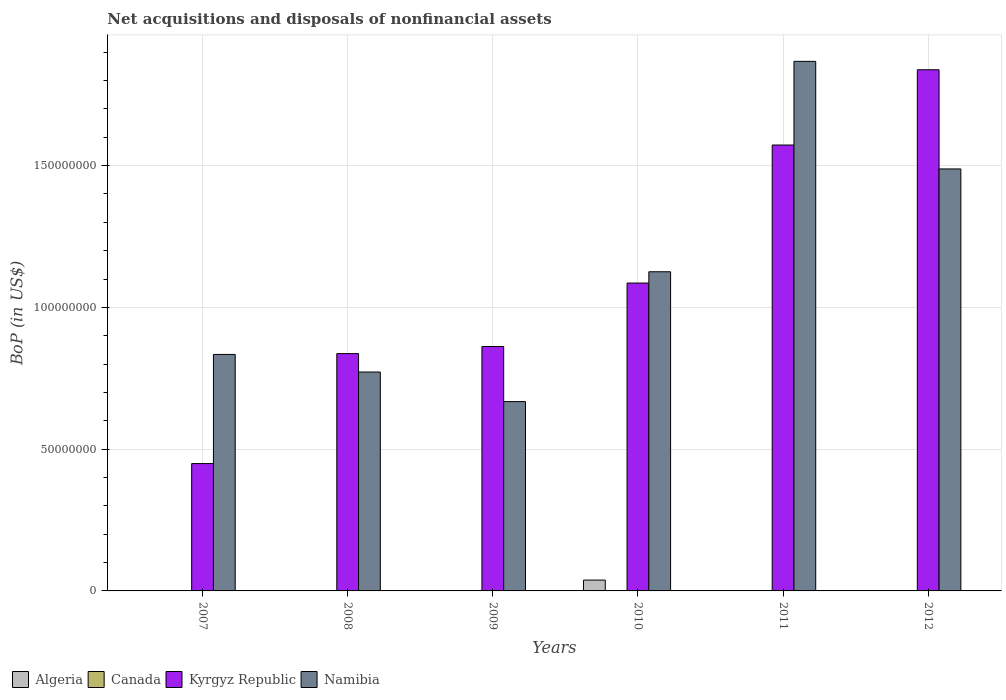How many different coloured bars are there?
Ensure brevity in your answer.  3. How many groups of bars are there?
Your answer should be compact. 6. Are the number of bars on each tick of the X-axis equal?
Provide a succinct answer. No. How many bars are there on the 1st tick from the left?
Ensure brevity in your answer.  2. How many bars are there on the 6th tick from the right?
Make the answer very short. 2. In how many cases, is the number of bars for a given year not equal to the number of legend labels?
Your answer should be very brief. 6. What is the Balance of Payments in Namibia in 2009?
Your answer should be compact. 6.68e+07. Across all years, what is the maximum Balance of Payments in Algeria?
Your answer should be compact. 3.82e+06. Across all years, what is the minimum Balance of Payments in Kyrgyz Republic?
Give a very brief answer. 4.49e+07. What is the total Balance of Payments in Kyrgyz Republic in the graph?
Your answer should be very brief. 6.64e+08. What is the difference between the Balance of Payments in Namibia in 2009 and that in 2012?
Offer a very short reply. -8.21e+07. What is the difference between the Balance of Payments in Canada in 2008 and the Balance of Payments in Kyrgyz Republic in 2007?
Keep it short and to the point. -4.49e+07. What is the average Balance of Payments in Namibia per year?
Ensure brevity in your answer.  1.13e+08. In the year 2010, what is the difference between the Balance of Payments in Namibia and Balance of Payments in Kyrgyz Republic?
Offer a terse response. 3.98e+06. In how many years, is the Balance of Payments in Algeria greater than 70000000 US$?
Make the answer very short. 0. What is the ratio of the Balance of Payments in Namibia in 2008 to that in 2011?
Provide a short and direct response. 0.41. What is the difference between the highest and the second highest Balance of Payments in Namibia?
Make the answer very short. 3.79e+07. What is the difference between the highest and the lowest Balance of Payments in Algeria?
Your response must be concise. 3.82e+06. In how many years, is the Balance of Payments in Namibia greater than the average Balance of Payments in Namibia taken over all years?
Your answer should be compact. 2. Is it the case that in every year, the sum of the Balance of Payments in Algeria and Balance of Payments in Namibia is greater than the sum of Balance of Payments in Kyrgyz Republic and Balance of Payments in Canada?
Your answer should be very brief. No. How many years are there in the graph?
Offer a terse response. 6. Does the graph contain any zero values?
Give a very brief answer. Yes. Does the graph contain grids?
Your answer should be compact. Yes. Where does the legend appear in the graph?
Ensure brevity in your answer.  Bottom left. How many legend labels are there?
Offer a terse response. 4. How are the legend labels stacked?
Your answer should be compact. Horizontal. What is the title of the graph?
Provide a succinct answer. Net acquisitions and disposals of nonfinancial assets. What is the label or title of the Y-axis?
Your answer should be compact. BoP (in US$). What is the BoP (in US$) in Kyrgyz Republic in 2007?
Your answer should be very brief. 4.49e+07. What is the BoP (in US$) in Namibia in 2007?
Provide a succinct answer. 8.34e+07. What is the BoP (in US$) in Algeria in 2008?
Offer a terse response. 0. What is the BoP (in US$) of Canada in 2008?
Your answer should be very brief. 0. What is the BoP (in US$) of Kyrgyz Republic in 2008?
Your response must be concise. 8.37e+07. What is the BoP (in US$) in Namibia in 2008?
Give a very brief answer. 7.72e+07. What is the BoP (in US$) of Kyrgyz Republic in 2009?
Ensure brevity in your answer.  8.62e+07. What is the BoP (in US$) of Namibia in 2009?
Offer a terse response. 6.68e+07. What is the BoP (in US$) in Algeria in 2010?
Keep it short and to the point. 3.82e+06. What is the BoP (in US$) in Canada in 2010?
Provide a succinct answer. 0. What is the BoP (in US$) in Kyrgyz Republic in 2010?
Ensure brevity in your answer.  1.09e+08. What is the BoP (in US$) of Namibia in 2010?
Offer a terse response. 1.13e+08. What is the BoP (in US$) of Algeria in 2011?
Keep it short and to the point. 0. What is the BoP (in US$) of Canada in 2011?
Your response must be concise. 0. What is the BoP (in US$) in Kyrgyz Republic in 2011?
Offer a very short reply. 1.57e+08. What is the BoP (in US$) in Namibia in 2011?
Provide a short and direct response. 1.87e+08. What is the BoP (in US$) in Canada in 2012?
Your response must be concise. 0. What is the BoP (in US$) of Kyrgyz Republic in 2012?
Offer a terse response. 1.84e+08. What is the BoP (in US$) of Namibia in 2012?
Ensure brevity in your answer.  1.49e+08. Across all years, what is the maximum BoP (in US$) in Algeria?
Give a very brief answer. 3.82e+06. Across all years, what is the maximum BoP (in US$) in Kyrgyz Republic?
Give a very brief answer. 1.84e+08. Across all years, what is the maximum BoP (in US$) of Namibia?
Your answer should be compact. 1.87e+08. Across all years, what is the minimum BoP (in US$) of Algeria?
Provide a succinct answer. 0. Across all years, what is the minimum BoP (in US$) in Kyrgyz Republic?
Provide a succinct answer. 4.49e+07. Across all years, what is the minimum BoP (in US$) in Namibia?
Provide a short and direct response. 6.68e+07. What is the total BoP (in US$) of Algeria in the graph?
Give a very brief answer. 3.82e+06. What is the total BoP (in US$) in Kyrgyz Republic in the graph?
Your answer should be very brief. 6.64e+08. What is the total BoP (in US$) of Namibia in the graph?
Give a very brief answer. 6.76e+08. What is the difference between the BoP (in US$) in Kyrgyz Republic in 2007 and that in 2008?
Offer a very short reply. -3.88e+07. What is the difference between the BoP (in US$) in Namibia in 2007 and that in 2008?
Provide a short and direct response. 6.20e+06. What is the difference between the BoP (in US$) in Kyrgyz Republic in 2007 and that in 2009?
Your answer should be compact. -4.13e+07. What is the difference between the BoP (in US$) of Namibia in 2007 and that in 2009?
Offer a terse response. 1.66e+07. What is the difference between the BoP (in US$) of Kyrgyz Republic in 2007 and that in 2010?
Provide a short and direct response. -6.37e+07. What is the difference between the BoP (in US$) in Namibia in 2007 and that in 2010?
Ensure brevity in your answer.  -2.92e+07. What is the difference between the BoP (in US$) in Kyrgyz Republic in 2007 and that in 2011?
Keep it short and to the point. -1.12e+08. What is the difference between the BoP (in US$) in Namibia in 2007 and that in 2011?
Provide a succinct answer. -1.03e+08. What is the difference between the BoP (in US$) in Kyrgyz Republic in 2007 and that in 2012?
Your answer should be very brief. -1.39e+08. What is the difference between the BoP (in US$) of Namibia in 2007 and that in 2012?
Provide a succinct answer. -6.54e+07. What is the difference between the BoP (in US$) in Kyrgyz Republic in 2008 and that in 2009?
Offer a very short reply. -2.51e+06. What is the difference between the BoP (in US$) in Namibia in 2008 and that in 2009?
Give a very brief answer. 1.04e+07. What is the difference between the BoP (in US$) in Kyrgyz Republic in 2008 and that in 2010?
Your answer should be compact. -2.49e+07. What is the difference between the BoP (in US$) of Namibia in 2008 and that in 2010?
Provide a short and direct response. -3.54e+07. What is the difference between the BoP (in US$) of Kyrgyz Republic in 2008 and that in 2011?
Offer a very short reply. -7.36e+07. What is the difference between the BoP (in US$) of Namibia in 2008 and that in 2011?
Your answer should be very brief. -1.10e+08. What is the difference between the BoP (in US$) in Kyrgyz Republic in 2008 and that in 2012?
Your answer should be compact. -1.00e+08. What is the difference between the BoP (in US$) of Namibia in 2008 and that in 2012?
Your response must be concise. -7.16e+07. What is the difference between the BoP (in US$) in Kyrgyz Republic in 2009 and that in 2010?
Offer a terse response. -2.24e+07. What is the difference between the BoP (in US$) in Namibia in 2009 and that in 2010?
Provide a short and direct response. -4.58e+07. What is the difference between the BoP (in US$) in Kyrgyz Republic in 2009 and that in 2011?
Offer a terse response. -7.11e+07. What is the difference between the BoP (in US$) in Namibia in 2009 and that in 2011?
Offer a terse response. -1.20e+08. What is the difference between the BoP (in US$) in Kyrgyz Republic in 2009 and that in 2012?
Your response must be concise. -9.76e+07. What is the difference between the BoP (in US$) of Namibia in 2009 and that in 2012?
Give a very brief answer. -8.21e+07. What is the difference between the BoP (in US$) in Kyrgyz Republic in 2010 and that in 2011?
Your response must be concise. -4.87e+07. What is the difference between the BoP (in US$) of Namibia in 2010 and that in 2011?
Provide a short and direct response. -7.42e+07. What is the difference between the BoP (in US$) of Kyrgyz Republic in 2010 and that in 2012?
Offer a very short reply. -7.52e+07. What is the difference between the BoP (in US$) of Namibia in 2010 and that in 2012?
Keep it short and to the point. -3.63e+07. What is the difference between the BoP (in US$) of Kyrgyz Republic in 2011 and that in 2012?
Provide a short and direct response. -2.65e+07. What is the difference between the BoP (in US$) of Namibia in 2011 and that in 2012?
Your answer should be very brief. 3.79e+07. What is the difference between the BoP (in US$) of Kyrgyz Republic in 2007 and the BoP (in US$) of Namibia in 2008?
Provide a short and direct response. -3.23e+07. What is the difference between the BoP (in US$) of Kyrgyz Republic in 2007 and the BoP (in US$) of Namibia in 2009?
Ensure brevity in your answer.  -2.19e+07. What is the difference between the BoP (in US$) of Kyrgyz Republic in 2007 and the BoP (in US$) of Namibia in 2010?
Provide a short and direct response. -6.76e+07. What is the difference between the BoP (in US$) of Kyrgyz Republic in 2007 and the BoP (in US$) of Namibia in 2011?
Offer a very short reply. -1.42e+08. What is the difference between the BoP (in US$) in Kyrgyz Republic in 2007 and the BoP (in US$) in Namibia in 2012?
Keep it short and to the point. -1.04e+08. What is the difference between the BoP (in US$) in Kyrgyz Republic in 2008 and the BoP (in US$) in Namibia in 2009?
Offer a very short reply. 1.69e+07. What is the difference between the BoP (in US$) in Kyrgyz Republic in 2008 and the BoP (in US$) in Namibia in 2010?
Your answer should be very brief. -2.89e+07. What is the difference between the BoP (in US$) of Kyrgyz Republic in 2008 and the BoP (in US$) of Namibia in 2011?
Offer a very short reply. -1.03e+08. What is the difference between the BoP (in US$) of Kyrgyz Republic in 2008 and the BoP (in US$) of Namibia in 2012?
Your answer should be compact. -6.51e+07. What is the difference between the BoP (in US$) of Kyrgyz Republic in 2009 and the BoP (in US$) of Namibia in 2010?
Provide a succinct answer. -2.64e+07. What is the difference between the BoP (in US$) of Kyrgyz Republic in 2009 and the BoP (in US$) of Namibia in 2011?
Your answer should be compact. -1.01e+08. What is the difference between the BoP (in US$) in Kyrgyz Republic in 2009 and the BoP (in US$) in Namibia in 2012?
Provide a succinct answer. -6.26e+07. What is the difference between the BoP (in US$) in Algeria in 2010 and the BoP (in US$) in Kyrgyz Republic in 2011?
Offer a terse response. -1.53e+08. What is the difference between the BoP (in US$) in Algeria in 2010 and the BoP (in US$) in Namibia in 2011?
Offer a very short reply. -1.83e+08. What is the difference between the BoP (in US$) in Kyrgyz Republic in 2010 and the BoP (in US$) in Namibia in 2011?
Your response must be concise. -7.82e+07. What is the difference between the BoP (in US$) of Algeria in 2010 and the BoP (in US$) of Kyrgyz Republic in 2012?
Your response must be concise. -1.80e+08. What is the difference between the BoP (in US$) in Algeria in 2010 and the BoP (in US$) in Namibia in 2012?
Ensure brevity in your answer.  -1.45e+08. What is the difference between the BoP (in US$) of Kyrgyz Republic in 2010 and the BoP (in US$) of Namibia in 2012?
Make the answer very short. -4.02e+07. What is the difference between the BoP (in US$) of Kyrgyz Republic in 2011 and the BoP (in US$) of Namibia in 2012?
Offer a very short reply. 8.43e+06. What is the average BoP (in US$) of Algeria per year?
Your response must be concise. 6.37e+05. What is the average BoP (in US$) in Kyrgyz Republic per year?
Provide a succinct answer. 1.11e+08. What is the average BoP (in US$) of Namibia per year?
Offer a terse response. 1.13e+08. In the year 2007, what is the difference between the BoP (in US$) in Kyrgyz Republic and BoP (in US$) in Namibia?
Keep it short and to the point. -3.85e+07. In the year 2008, what is the difference between the BoP (in US$) in Kyrgyz Republic and BoP (in US$) in Namibia?
Make the answer very short. 6.49e+06. In the year 2009, what is the difference between the BoP (in US$) of Kyrgyz Republic and BoP (in US$) of Namibia?
Ensure brevity in your answer.  1.94e+07. In the year 2010, what is the difference between the BoP (in US$) in Algeria and BoP (in US$) in Kyrgyz Republic?
Provide a short and direct response. -1.05e+08. In the year 2010, what is the difference between the BoP (in US$) of Algeria and BoP (in US$) of Namibia?
Your answer should be compact. -1.09e+08. In the year 2010, what is the difference between the BoP (in US$) in Kyrgyz Republic and BoP (in US$) in Namibia?
Offer a terse response. -3.98e+06. In the year 2011, what is the difference between the BoP (in US$) in Kyrgyz Republic and BoP (in US$) in Namibia?
Offer a very short reply. -2.95e+07. In the year 2012, what is the difference between the BoP (in US$) in Kyrgyz Republic and BoP (in US$) in Namibia?
Give a very brief answer. 3.50e+07. What is the ratio of the BoP (in US$) of Kyrgyz Republic in 2007 to that in 2008?
Provide a succinct answer. 0.54. What is the ratio of the BoP (in US$) in Namibia in 2007 to that in 2008?
Give a very brief answer. 1.08. What is the ratio of the BoP (in US$) of Kyrgyz Republic in 2007 to that in 2009?
Your response must be concise. 0.52. What is the ratio of the BoP (in US$) of Namibia in 2007 to that in 2009?
Your answer should be very brief. 1.25. What is the ratio of the BoP (in US$) of Kyrgyz Republic in 2007 to that in 2010?
Provide a succinct answer. 0.41. What is the ratio of the BoP (in US$) in Namibia in 2007 to that in 2010?
Provide a short and direct response. 0.74. What is the ratio of the BoP (in US$) of Kyrgyz Republic in 2007 to that in 2011?
Offer a very short reply. 0.29. What is the ratio of the BoP (in US$) in Namibia in 2007 to that in 2011?
Your answer should be compact. 0.45. What is the ratio of the BoP (in US$) in Kyrgyz Republic in 2007 to that in 2012?
Make the answer very short. 0.24. What is the ratio of the BoP (in US$) of Namibia in 2007 to that in 2012?
Provide a succinct answer. 0.56. What is the ratio of the BoP (in US$) in Kyrgyz Republic in 2008 to that in 2009?
Your response must be concise. 0.97. What is the ratio of the BoP (in US$) in Namibia in 2008 to that in 2009?
Provide a succinct answer. 1.16. What is the ratio of the BoP (in US$) of Kyrgyz Republic in 2008 to that in 2010?
Your response must be concise. 0.77. What is the ratio of the BoP (in US$) in Namibia in 2008 to that in 2010?
Your response must be concise. 0.69. What is the ratio of the BoP (in US$) in Kyrgyz Republic in 2008 to that in 2011?
Keep it short and to the point. 0.53. What is the ratio of the BoP (in US$) in Namibia in 2008 to that in 2011?
Make the answer very short. 0.41. What is the ratio of the BoP (in US$) of Kyrgyz Republic in 2008 to that in 2012?
Provide a short and direct response. 0.46. What is the ratio of the BoP (in US$) in Namibia in 2008 to that in 2012?
Offer a very short reply. 0.52. What is the ratio of the BoP (in US$) of Kyrgyz Republic in 2009 to that in 2010?
Provide a short and direct response. 0.79. What is the ratio of the BoP (in US$) in Namibia in 2009 to that in 2010?
Your answer should be very brief. 0.59. What is the ratio of the BoP (in US$) of Kyrgyz Republic in 2009 to that in 2011?
Your response must be concise. 0.55. What is the ratio of the BoP (in US$) in Namibia in 2009 to that in 2011?
Provide a short and direct response. 0.36. What is the ratio of the BoP (in US$) in Kyrgyz Republic in 2009 to that in 2012?
Your response must be concise. 0.47. What is the ratio of the BoP (in US$) in Namibia in 2009 to that in 2012?
Provide a short and direct response. 0.45. What is the ratio of the BoP (in US$) of Kyrgyz Republic in 2010 to that in 2011?
Keep it short and to the point. 0.69. What is the ratio of the BoP (in US$) of Namibia in 2010 to that in 2011?
Give a very brief answer. 0.6. What is the ratio of the BoP (in US$) of Kyrgyz Republic in 2010 to that in 2012?
Your answer should be compact. 0.59. What is the ratio of the BoP (in US$) in Namibia in 2010 to that in 2012?
Ensure brevity in your answer.  0.76. What is the ratio of the BoP (in US$) of Kyrgyz Republic in 2011 to that in 2012?
Provide a succinct answer. 0.86. What is the ratio of the BoP (in US$) of Namibia in 2011 to that in 2012?
Your answer should be very brief. 1.25. What is the difference between the highest and the second highest BoP (in US$) in Kyrgyz Republic?
Your response must be concise. 2.65e+07. What is the difference between the highest and the second highest BoP (in US$) of Namibia?
Your response must be concise. 3.79e+07. What is the difference between the highest and the lowest BoP (in US$) in Algeria?
Make the answer very short. 3.82e+06. What is the difference between the highest and the lowest BoP (in US$) of Kyrgyz Republic?
Your answer should be compact. 1.39e+08. What is the difference between the highest and the lowest BoP (in US$) of Namibia?
Offer a very short reply. 1.20e+08. 